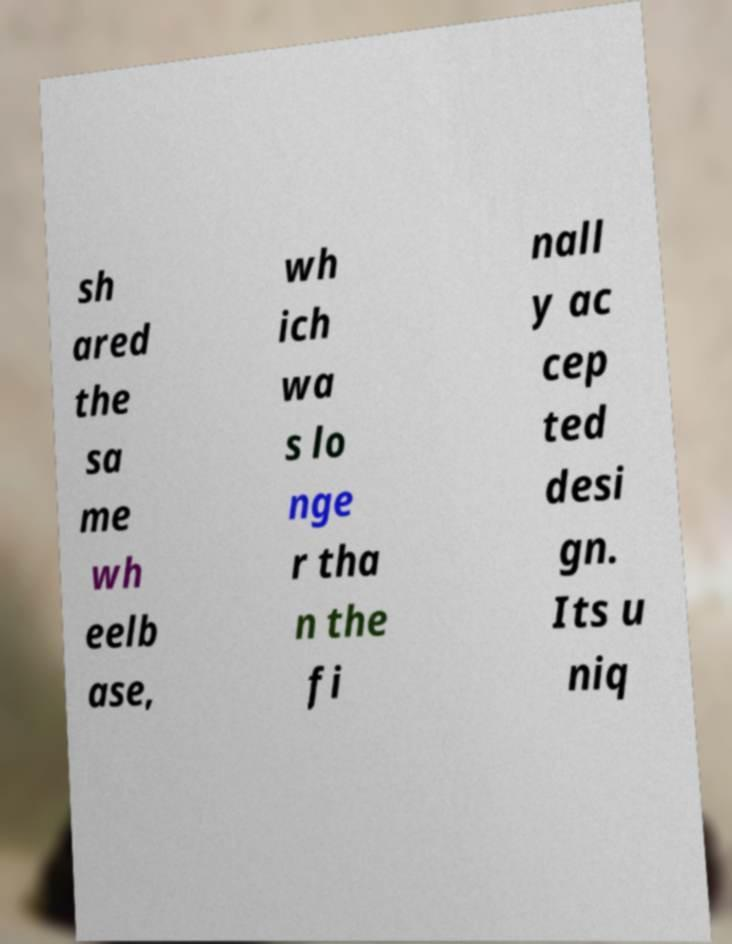Please read and relay the text visible in this image. What does it say? sh ared the sa me wh eelb ase, wh ich wa s lo nge r tha n the fi nall y ac cep ted desi gn. Its u niq 